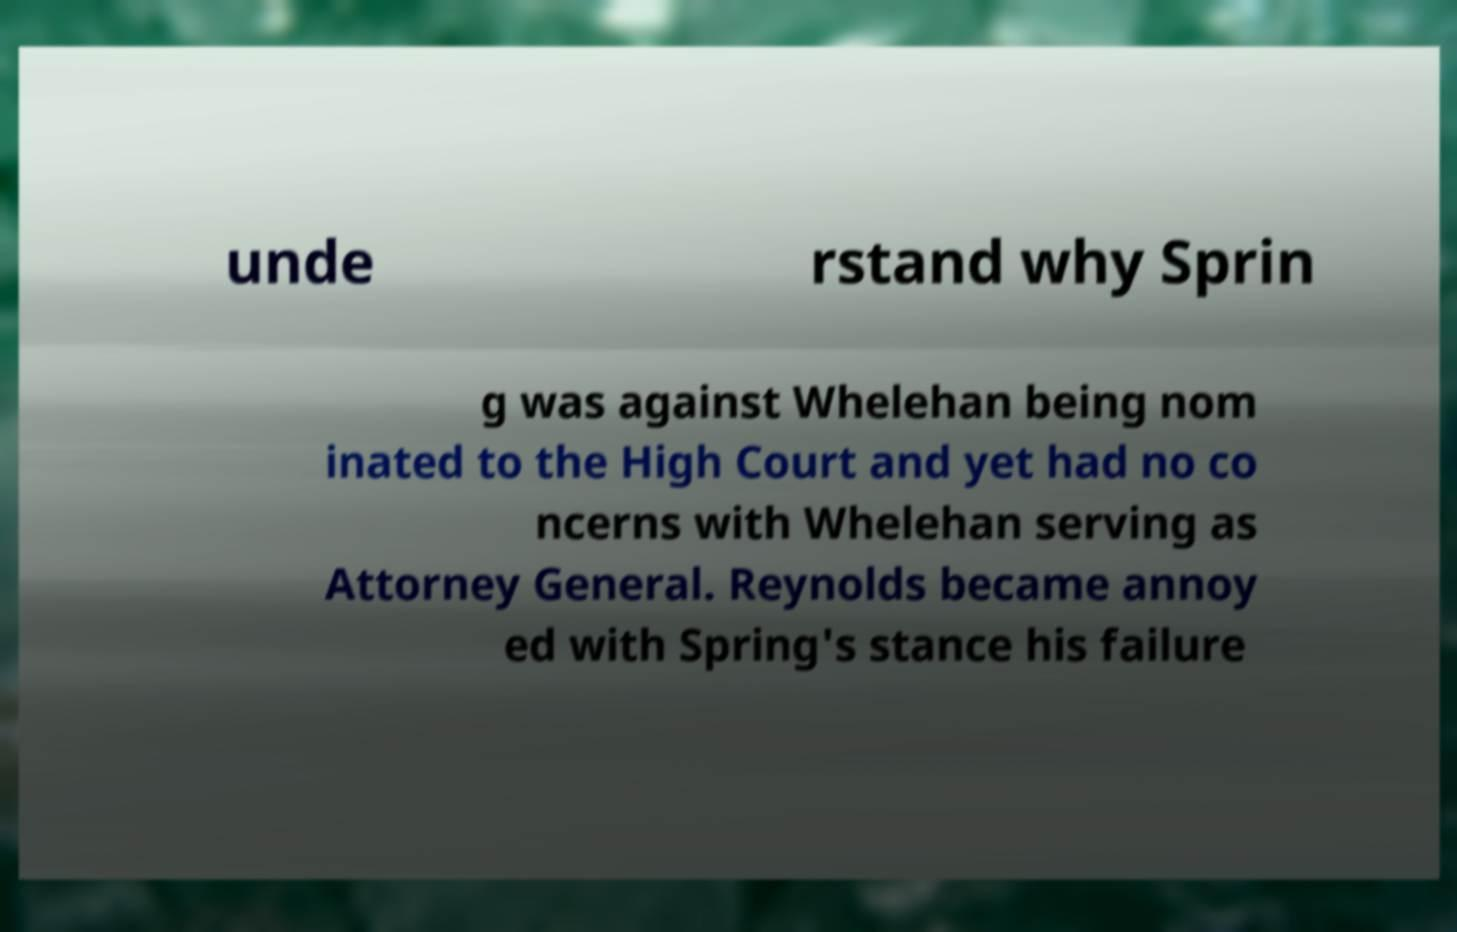Can you read and provide the text displayed in the image?This photo seems to have some interesting text. Can you extract and type it out for me? unde rstand why Sprin g was against Whelehan being nom inated to the High Court and yet had no co ncerns with Whelehan serving as Attorney General. Reynolds became annoy ed with Spring's stance his failure 